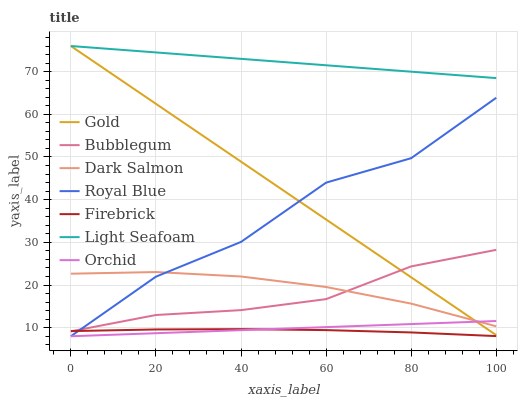Does Dark Salmon have the minimum area under the curve?
Answer yes or no. No. Does Dark Salmon have the maximum area under the curve?
Answer yes or no. No. Is Firebrick the smoothest?
Answer yes or no. No. Is Firebrick the roughest?
Answer yes or no. No. Does Firebrick have the lowest value?
Answer yes or no. No. Does Dark Salmon have the highest value?
Answer yes or no. No. Is Orchid less than Bubblegum?
Answer yes or no. Yes. Is Light Seafoam greater than Orchid?
Answer yes or no. Yes. Does Orchid intersect Bubblegum?
Answer yes or no. No. 